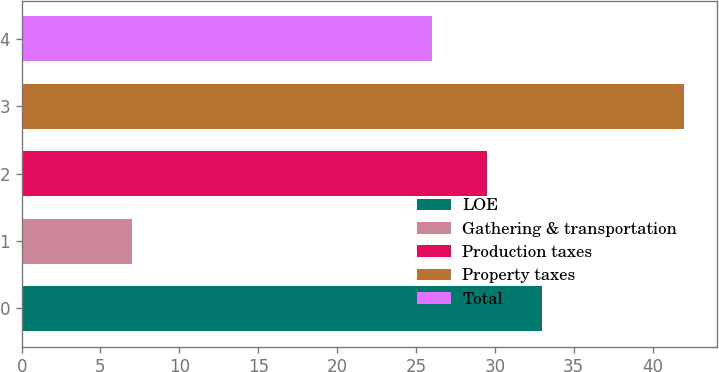Convert chart to OTSL. <chart><loc_0><loc_0><loc_500><loc_500><bar_chart><fcel>LOE<fcel>Gathering & transportation<fcel>Production taxes<fcel>Property taxes<fcel>Total<nl><fcel>33<fcel>7<fcel>29.5<fcel>42<fcel>26<nl></chart> 